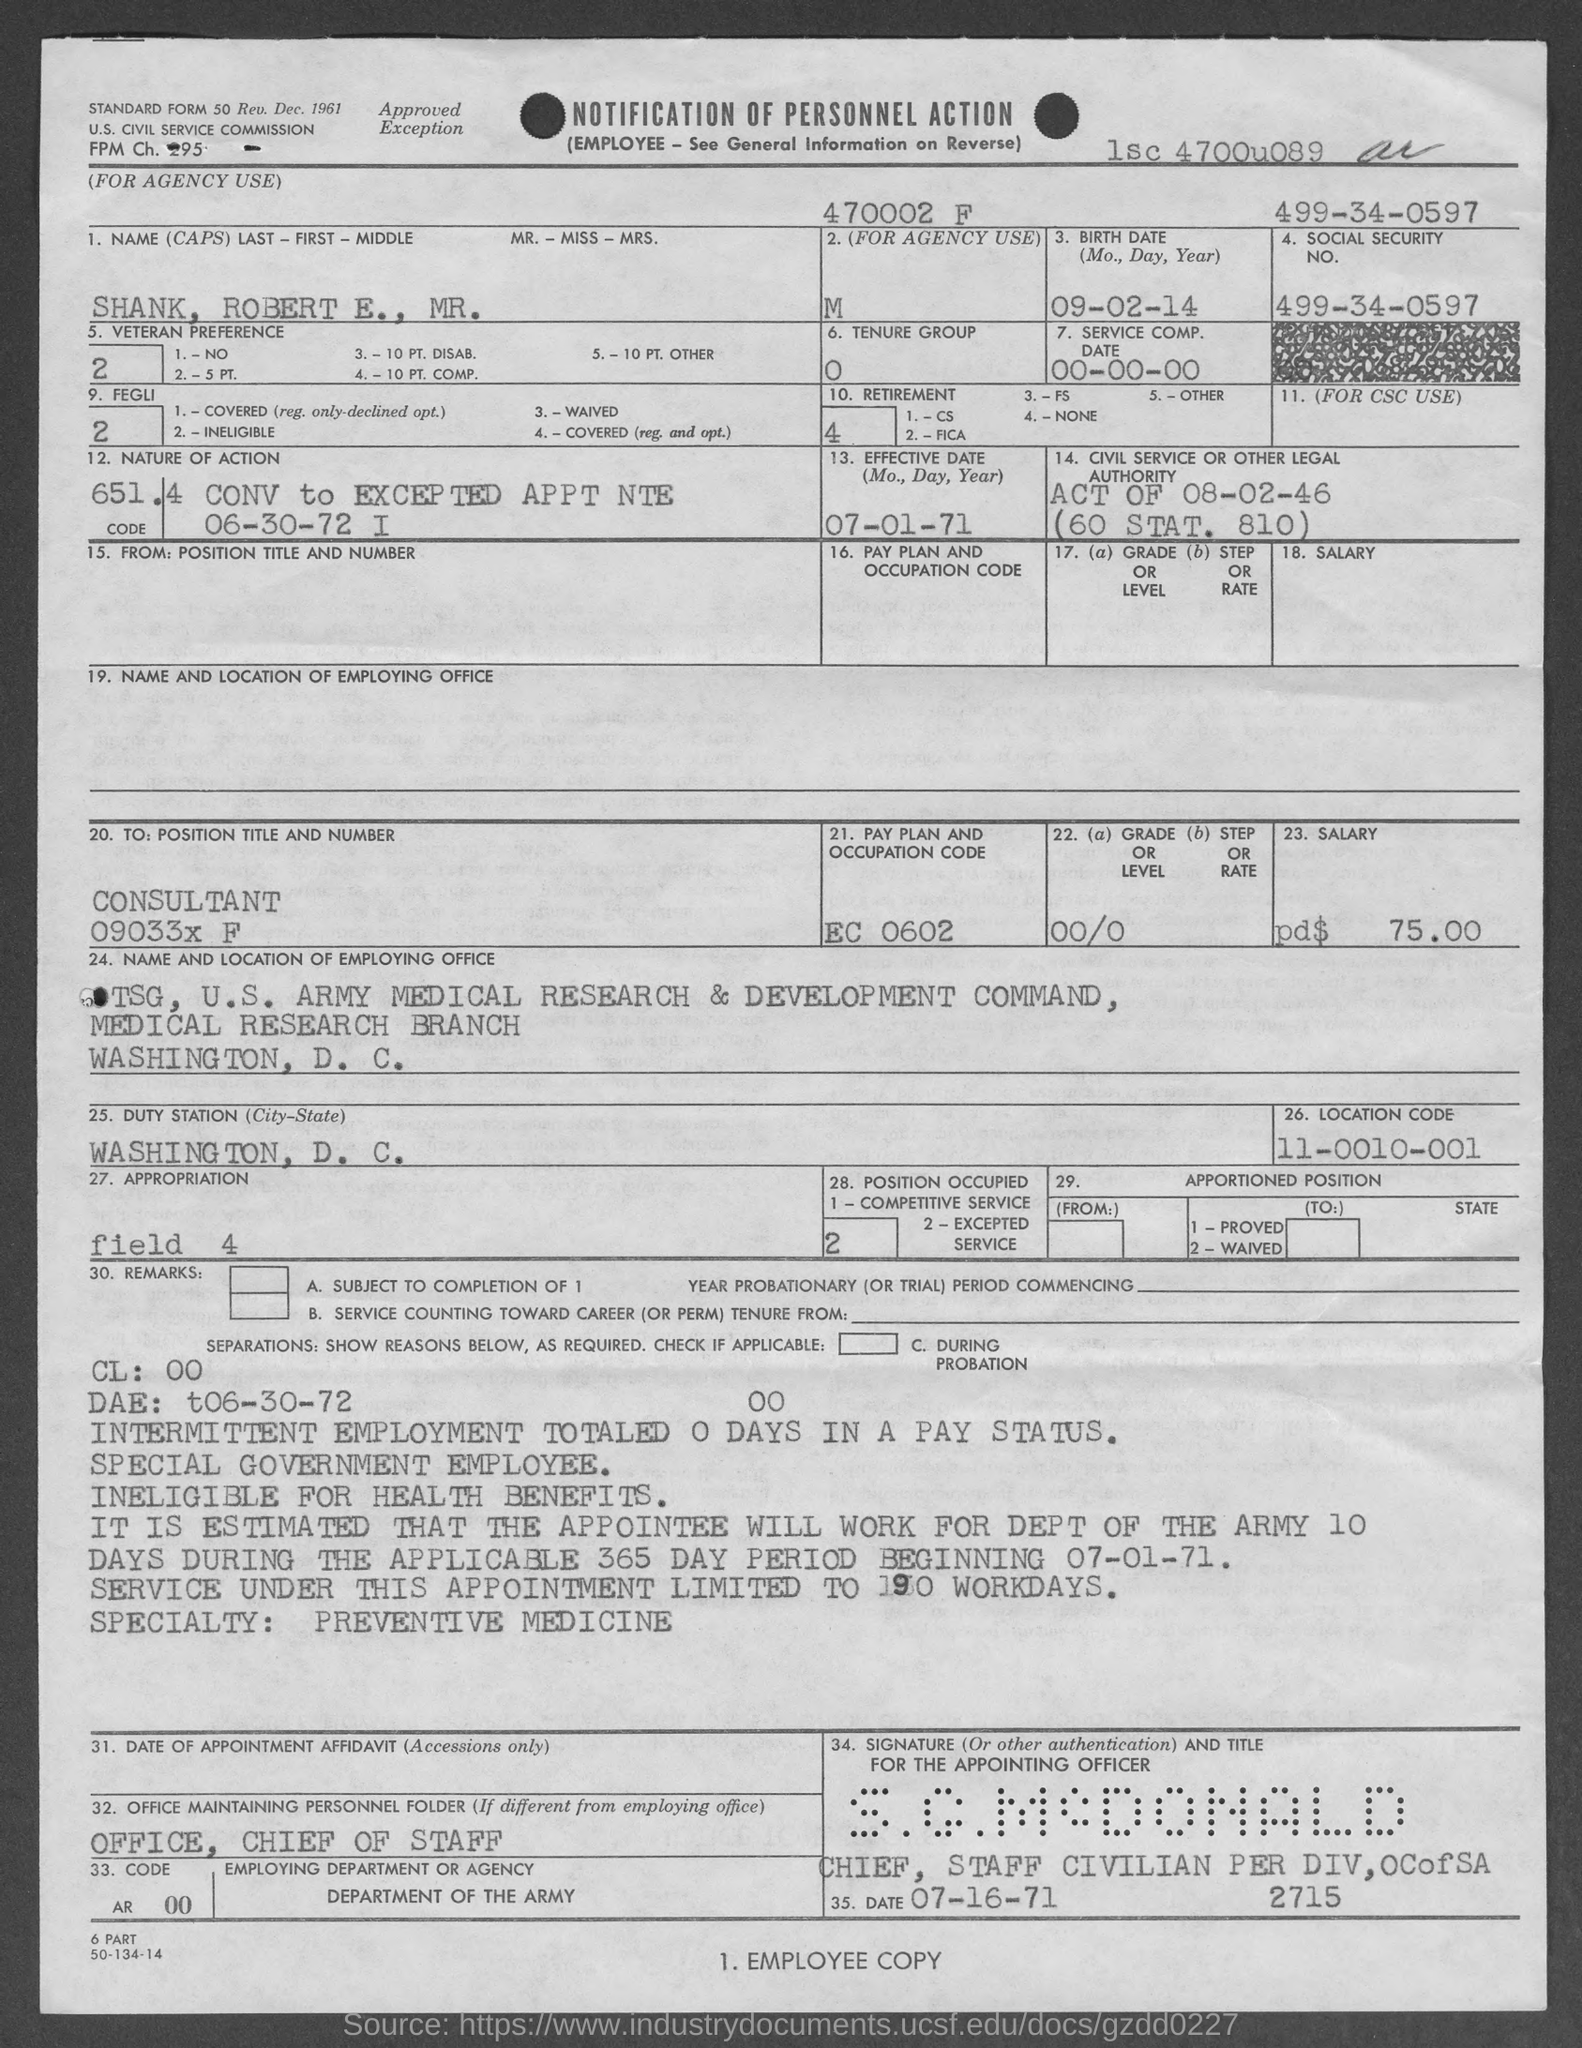Indicate a few pertinent items in this graphic. The pay plan and occupation code listed on the form is EC 0602. The location code provided in the form is 11-0010-001... The position title and number of Mr. Robert E. Shank is Consultant 09033x F. The Service Composition date mentioned in the form is 00-00-00, which is an invalid date. The date of birth of Mr. Robert E. Shank is September 2, 1914. 